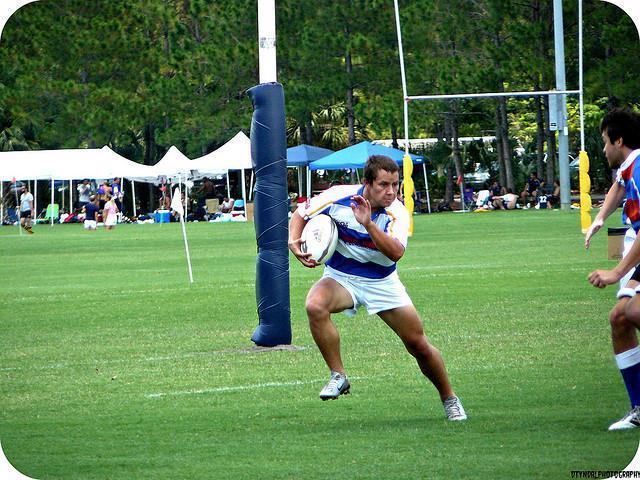How many people are there?
Give a very brief answer. 3. How many kites are flying?
Give a very brief answer. 0. 